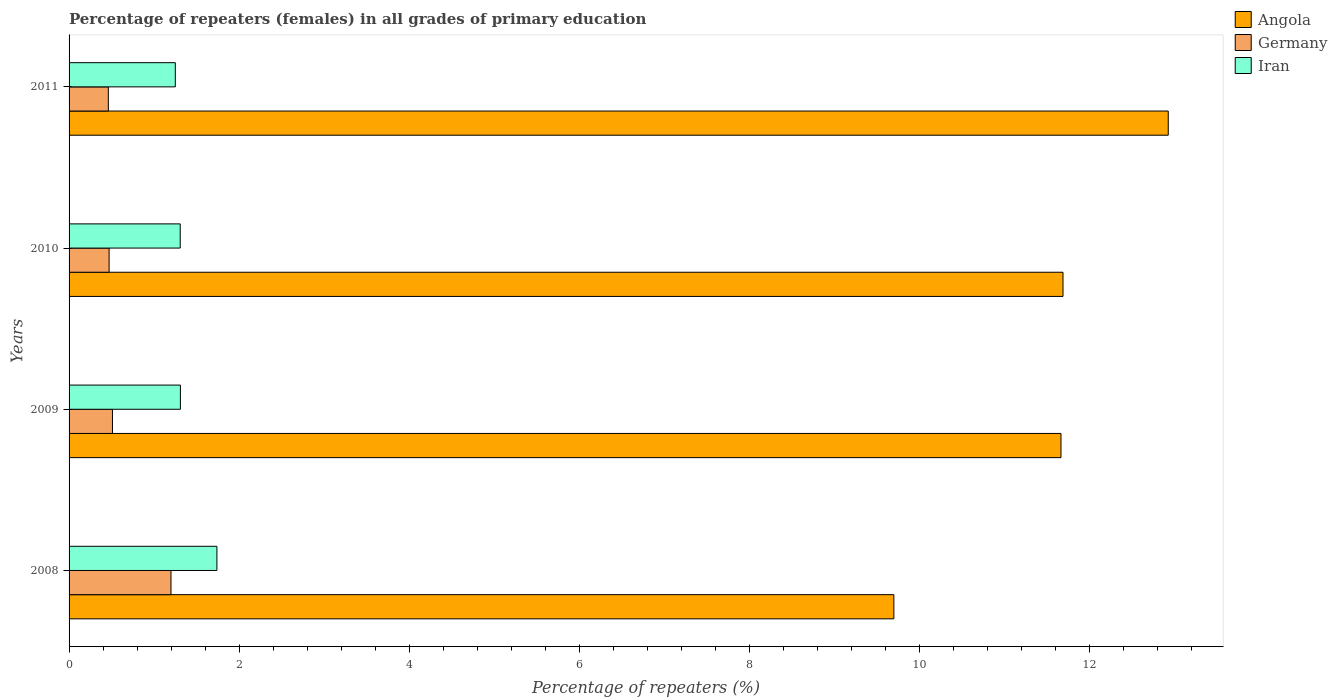Are the number of bars on each tick of the Y-axis equal?
Keep it short and to the point. Yes. How many bars are there on the 2nd tick from the top?
Provide a short and direct response. 3. How many bars are there on the 3rd tick from the bottom?
Your response must be concise. 3. What is the percentage of repeaters (females) in Germany in 2008?
Offer a very short reply. 1.2. Across all years, what is the maximum percentage of repeaters (females) in Germany?
Give a very brief answer. 1.2. Across all years, what is the minimum percentage of repeaters (females) in Iran?
Provide a short and direct response. 1.25. What is the total percentage of repeaters (females) in Germany in the graph?
Make the answer very short. 2.64. What is the difference between the percentage of repeaters (females) in Angola in 2008 and that in 2009?
Your answer should be very brief. -1.97. What is the difference between the percentage of repeaters (females) in Iran in 2009 and the percentage of repeaters (females) in Germany in 2008?
Your answer should be compact. 0.11. What is the average percentage of repeaters (females) in Angola per year?
Provide a short and direct response. 11.5. In the year 2010, what is the difference between the percentage of repeaters (females) in Iran and percentage of repeaters (females) in Germany?
Provide a short and direct response. 0.84. What is the ratio of the percentage of repeaters (females) in Germany in 2009 to that in 2010?
Keep it short and to the point. 1.08. Is the difference between the percentage of repeaters (females) in Iran in 2008 and 2010 greater than the difference between the percentage of repeaters (females) in Germany in 2008 and 2010?
Provide a short and direct response. No. What is the difference between the highest and the second highest percentage of repeaters (females) in Iran?
Your answer should be very brief. 0.43. What is the difference between the highest and the lowest percentage of repeaters (females) in Iran?
Offer a very short reply. 0.49. What does the 2nd bar from the top in 2009 represents?
Ensure brevity in your answer.  Germany. What does the 1st bar from the bottom in 2010 represents?
Your answer should be compact. Angola. Is it the case that in every year, the sum of the percentage of repeaters (females) in Germany and percentage of repeaters (females) in Iran is greater than the percentage of repeaters (females) in Angola?
Offer a very short reply. No. Are all the bars in the graph horizontal?
Provide a succinct answer. Yes. How many years are there in the graph?
Give a very brief answer. 4. What is the difference between two consecutive major ticks on the X-axis?
Provide a short and direct response. 2. Does the graph contain grids?
Make the answer very short. No. How many legend labels are there?
Ensure brevity in your answer.  3. What is the title of the graph?
Offer a very short reply. Percentage of repeaters (females) in all grades of primary education. What is the label or title of the X-axis?
Give a very brief answer. Percentage of repeaters (%). What is the label or title of the Y-axis?
Offer a very short reply. Years. What is the Percentage of repeaters (%) in Angola in 2008?
Provide a succinct answer. 9.7. What is the Percentage of repeaters (%) in Germany in 2008?
Your answer should be compact. 1.2. What is the Percentage of repeaters (%) in Iran in 2008?
Give a very brief answer. 1.74. What is the Percentage of repeaters (%) in Angola in 2009?
Offer a terse response. 11.67. What is the Percentage of repeaters (%) of Germany in 2009?
Offer a very short reply. 0.51. What is the Percentage of repeaters (%) of Iran in 2009?
Provide a succinct answer. 1.31. What is the Percentage of repeaters (%) of Angola in 2010?
Provide a short and direct response. 11.69. What is the Percentage of repeaters (%) in Germany in 2010?
Your response must be concise. 0.47. What is the Percentage of repeaters (%) of Iran in 2010?
Offer a very short reply. 1.31. What is the Percentage of repeaters (%) in Angola in 2011?
Provide a short and direct response. 12.93. What is the Percentage of repeaters (%) in Germany in 2011?
Ensure brevity in your answer.  0.46. What is the Percentage of repeaters (%) in Iran in 2011?
Offer a terse response. 1.25. Across all years, what is the maximum Percentage of repeaters (%) of Angola?
Give a very brief answer. 12.93. Across all years, what is the maximum Percentage of repeaters (%) of Germany?
Make the answer very short. 1.2. Across all years, what is the maximum Percentage of repeaters (%) of Iran?
Offer a terse response. 1.74. Across all years, what is the minimum Percentage of repeaters (%) of Angola?
Your answer should be compact. 9.7. Across all years, what is the minimum Percentage of repeaters (%) in Germany?
Your answer should be very brief. 0.46. Across all years, what is the minimum Percentage of repeaters (%) of Iran?
Your answer should be very brief. 1.25. What is the total Percentage of repeaters (%) in Angola in the graph?
Offer a terse response. 45.99. What is the total Percentage of repeaters (%) of Germany in the graph?
Your response must be concise. 2.64. What is the total Percentage of repeaters (%) in Iran in the graph?
Provide a succinct answer. 5.61. What is the difference between the Percentage of repeaters (%) of Angola in 2008 and that in 2009?
Provide a succinct answer. -1.97. What is the difference between the Percentage of repeaters (%) of Germany in 2008 and that in 2009?
Ensure brevity in your answer.  0.69. What is the difference between the Percentage of repeaters (%) of Iran in 2008 and that in 2009?
Give a very brief answer. 0.43. What is the difference between the Percentage of repeaters (%) in Angola in 2008 and that in 2010?
Provide a short and direct response. -1.99. What is the difference between the Percentage of repeaters (%) in Germany in 2008 and that in 2010?
Provide a short and direct response. 0.73. What is the difference between the Percentage of repeaters (%) in Iran in 2008 and that in 2010?
Keep it short and to the point. 0.43. What is the difference between the Percentage of repeaters (%) in Angola in 2008 and that in 2011?
Provide a short and direct response. -3.23. What is the difference between the Percentage of repeaters (%) of Germany in 2008 and that in 2011?
Offer a very short reply. 0.74. What is the difference between the Percentage of repeaters (%) in Iran in 2008 and that in 2011?
Your answer should be compact. 0.49. What is the difference between the Percentage of repeaters (%) of Angola in 2009 and that in 2010?
Make the answer very short. -0.02. What is the difference between the Percentage of repeaters (%) in Germany in 2009 and that in 2010?
Your answer should be very brief. 0.04. What is the difference between the Percentage of repeaters (%) in Iran in 2009 and that in 2010?
Keep it short and to the point. 0. What is the difference between the Percentage of repeaters (%) of Angola in 2009 and that in 2011?
Keep it short and to the point. -1.26. What is the difference between the Percentage of repeaters (%) of Germany in 2009 and that in 2011?
Give a very brief answer. 0.05. What is the difference between the Percentage of repeaters (%) of Angola in 2010 and that in 2011?
Provide a short and direct response. -1.24. What is the difference between the Percentage of repeaters (%) in Germany in 2010 and that in 2011?
Your answer should be very brief. 0.01. What is the difference between the Percentage of repeaters (%) in Iran in 2010 and that in 2011?
Offer a very short reply. 0.06. What is the difference between the Percentage of repeaters (%) in Angola in 2008 and the Percentage of repeaters (%) in Germany in 2009?
Your response must be concise. 9.19. What is the difference between the Percentage of repeaters (%) of Angola in 2008 and the Percentage of repeaters (%) of Iran in 2009?
Your response must be concise. 8.39. What is the difference between the Percentage of repeaters (%) of Germany in 2008 and the Percentage of repeaters (%) of Iran in 2009?
Offer a terse response. -0.11. What is the difference between the Percentage of repeaters (%) of Angola in 2008 and the Percentage of repeaters (%) of Germany in 2010?
Give a very brief answer. 9.23. What is the difference between the Percentage of repeaters (%) of Angola in 2008 and the Percentage of repeaters (%) of Iran in 2010?
Provide a succinct answer. 8.39. What is the difference between the Percentage of repeaters (%) of Germany in 2008 and the Percentage of repeaters (%) of Iran in 2010?
Ensure brevity in your answer.  -0.11. What is the difference between the Percentage of repeaters (%) of Angola in 2008 and the Percentage of repeaters (%) of Germany in 2011?
Give a very brief answer. 9.24. What is the difference between the Percentage of repeaters (%) in Angola in 2008 and the Percentage of repeaters (%) in Iran in 2011?
Your answer should be compact. 8.45. What is the difference between the Percentage of repeaters (%) of Germany in 2008 and the Percentage of repeaters (%) of Iran in 2011?
Your answer should be very brief. -0.05. What is the difference between the Percentage of repeaters (%) of Angola in 2009 and the Percentage of repeaters (%) of Germany in 2010?
Offer a terse response. 11.2. What is the difference between the Percentage of repeaters (%) in Angola in 2009 and the Percentage of repeaters (%) in Iran in 2010?
Offer a terse response. 10.36. What is the difference between the Percentage of repeaters (%) of Germany in 2009 and the Percentage of repeaters (%) of Iran in 2010?
Provide a succinct answer. -0.8. What is the difference between the Percentage of repeaters (%) in Angola in 2009 and the Percentage of repeaters (%) in Germany in 2011?
Ensure brevity in your answer.  11.21. What is the difference between the Percentage of repeaters (%) in Angola in 2009 and the Percentage of repeaters (%) in Iran in 2011?
Your response must be concise. 10.42. What is the difference between the Percentage of repeaters (%) of Germany in 2009 and the Percentage of repeaters (%) of Iran in 2011?
Keep it short and to the point. -0.74. What is the difference between the Percentage of repeaters (%) of Angola in 2010 and the Percentage of repeaters (%) of Germany in 2011?
Provide a succinct answer. 11.23. What is the difference between the Percentage of repeaters (%) of Angola in 2010 and the Percentage of repeaters (%) of Iran in 2011?
Your answer should be very brief. 10.44. What is the difference between the Percentage of repeaters (%) of Germany in 2010 and the Percentage of repeaters (%) of Iran in 2011?
Provide a short and direct response. -0.78. What is the average Percentage of repeaters (%) in Angola per year?
Provide a succinct answer. 11.5. What is the average Percentage of repeaters (%) in Germany per year?
Provide a succinct answer. 0.66. What is the average Percentage of repeaters (%) in Iran per year?
Keep it short and to the point. 1.4. In the year 2008, what is the difference between the Percentage of repeaters (%) in Angola and Percentage of repeaters (%) in Germany?
Offer a very short reply. 8.5. In the year 2008, what is the difference between the Percentage of repeaters (%) in Angola and Percentage of repeaters (%) in Iran?
Offer a very short reply. 7.96. In the year 2008, what is the difference between the Percentage of repeaters (%) of Germany and Percentage of repeaters (%) of Iran?
Keep it short and to the point. -0.54. In the year 2009, what is the difference between the Percentage of repeaters (%) of Angola and Percentage of repeaters (%) of Germany?
Your response must be concise. 11.16. In the year 2009, what is the difference between the Percentage of repeaters (%) of Angola and Percentage of repeaters (%) of Iran?
Offer a terse response. 10.36. In the year 2009, what is the difference between the Percentage of repeaters (%) in Germany and Percentage of repeaters (%) in Iran?
Give a very brief answer. -0.8. In the year 2010, what is the difference between the Percentage of repeaters (%) in Angola and Percentage of repeaters (%) in Germany?
Ensure brevity in your answer.  11.22. In the year 2010, what is the difference between the Percentage of repeaters (%) of Angola and Percentage of repeaters (%) of Iran?
Offer a terse response. 10.38. In the year 2010, what is the difference between the Percentage of repeaters (%) of Germany and Percentage of repeaters (%) of Iran?
Give a very brief answer. -0.84. In the year 2011, what is the difference between the Percentage of repeaters (%) in Angola and Percentage of repeaters (%) in Germany?
Ensure brevity in your answer.  12.47. In the year 2011, what is the difference between the Percentage of repeaters (%) of Angola and Percentage of repeaters (%) of Iran?
Make the answer very short. 11.68. In the year 2011, what is the difference between the Percentage of repeaters (%) in Germany and Percentage of repeaters (%) in Iran?
Give a very brief answer. -0.79. What is the ratio of the Percentage of repeaters (%) in Angola in 2008 to that in 2009?
Your response must be concise. 0.83. What is the ratio of the Percentage of repeaters (%) in Germany in 2008 to that in 2009?
Your answer should be very brief. 2.35. What is the ratio of the Percentage of repeaters (%) of Iran in 2008 to that in 2009?
Give a very brief answer. 1.33. What is the ratio of the Percentage of repeaters (%) of Angola in 2008 to that in 2010?
Ensure brevity in your answer.  0.83. What is the ratio of the Percentage of repeaters (%) of Germany in 2008 to that in 2010?
Your answer should be compact. 2.55. What is the ratio of the Percentage of repeaters (%) of Iran in 2008 to that in 2010?
Keep it short and to the point. 1.33. What is the ratio of the Percentage of repeaters (%) of Angola in 2008 to that in 2011?
Keep it short and to the point. 0.75. What is the ratio of the Percentage of repeaters (%) in Germany in 2008 to that in 2011?
Make the answer very short. 2.6. What is the ratio of the Percentage of repeaters (%) in Iran in 2008 to that in 2011?
Give a very brief answer. 1.39. What is the ratio of the Percentage of repeaters (%) in Angola in 2009 to that in 2010?
Your answer should be compact. 1. What is the ratio of the Percentage of repeaters (%) in Germany in 2009 to that in 2010?
Your response must be concise. 1.08. What is the ratio of the Percentage of repeaters (%) in Angola in 2009 to that in 2011?
Your response must be concise. 0.9. What is the ratio of the Percentage of repeaters (%) of Germany in 2009 to that in 2011?
Your answer should be compact. 1.11. What is the ratio of the Percentage of repeaters (%) in Iran in 2009 to that in 2011?
Offer a terse response. 1.05. What is the ratio of the Percentage of repeaters (%) of Angola in 2010 to that in 2011?
Your answer should be compact. 0.9. What is the ratio of the Percentage of repeaters (%) in Germany in 2010 to that in 2011?
Ensure brevity in your answer.  1.02. What is the ratio of the Percentage of repeaters (%) in Iran in 2010 to that in 2011?
Provide a short and direct response. 1.05. What is the difference between the highest and the second highest Percentage of repeaters (%) of Angola?
Give a very brief answer. 1.24. What is the difference between the highest and the second highest Percentage of repeaters (%) of Germany?
Your answer should be very brief. 0.69. What is the difference between the highest and the second highest Percentage of repeaters (%) of Iran?
Provide a succinct answer. 0.43. What is the difference between the highest and the lowest Percentage of repeaters (%) of Angola?
Your answer should be very brief. 3.23. What is the difference between the highest and the lowest Percentage of repeaters (%) of Germany?
Provide a succinct answer. 0.74. What is the difference between the highest and the lowest Percentage of repeaters (%) of Iran?
Ensure brevity in your answer.  0.49. 